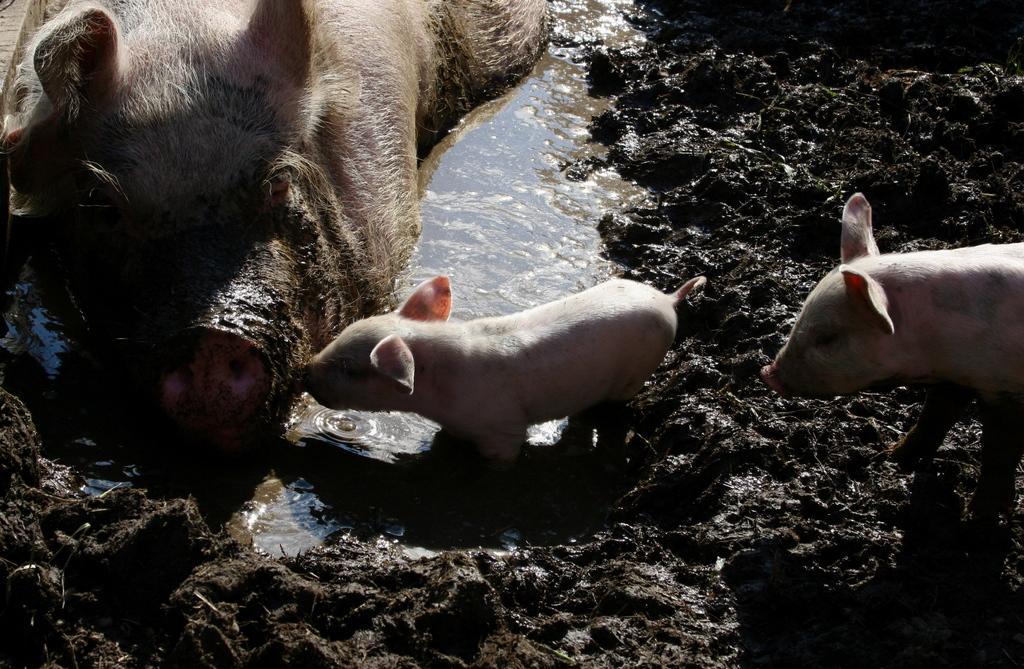Can you describe this image briefly? In this picture we can see pigs, water and mud. 